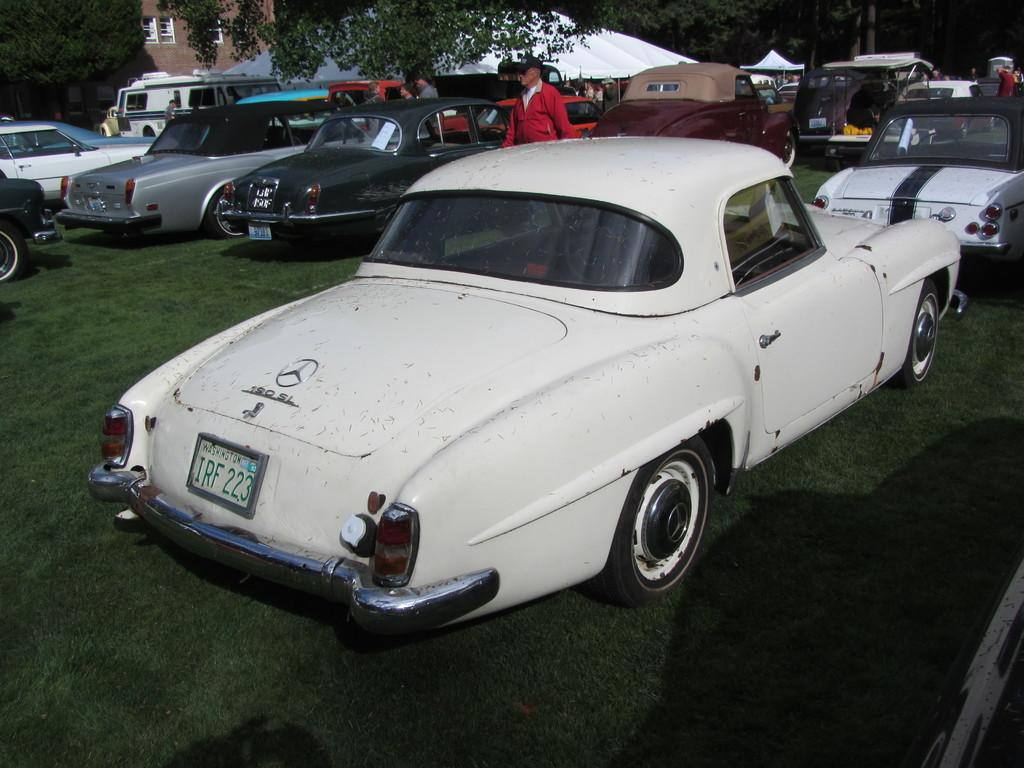What is the main subject of the image? The main subject of the image is fleets of cars. Can you describe the people in the image? There is a group of people on the grass in the image. What can be seen in the background of the image? There are tents, buildings, and trees in the background of the image. What might be the time of day when the image was taken? The image may have been taken during the night, as there is no clear indication of daylight. What type of loaf is being shared among the people in the image? There is no loaf present in the image; the people are on the grass, and the main subject is the fleets of cars. What is the level of fog in the image? There is no fog present in the image; it features such as buildings, trees, and tents are clearly visible in the background. 